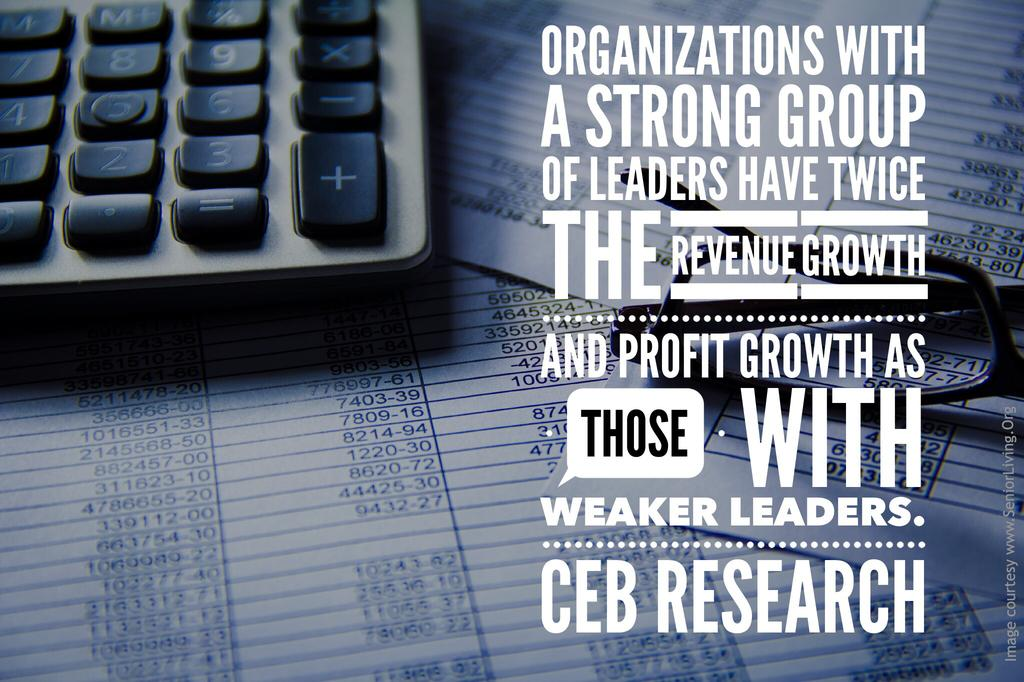Provide a one-sentence caption for the provided image. An advertisement showing a calculator on top of spreadsheets with text talking about strong leaders versus weak leaders. 